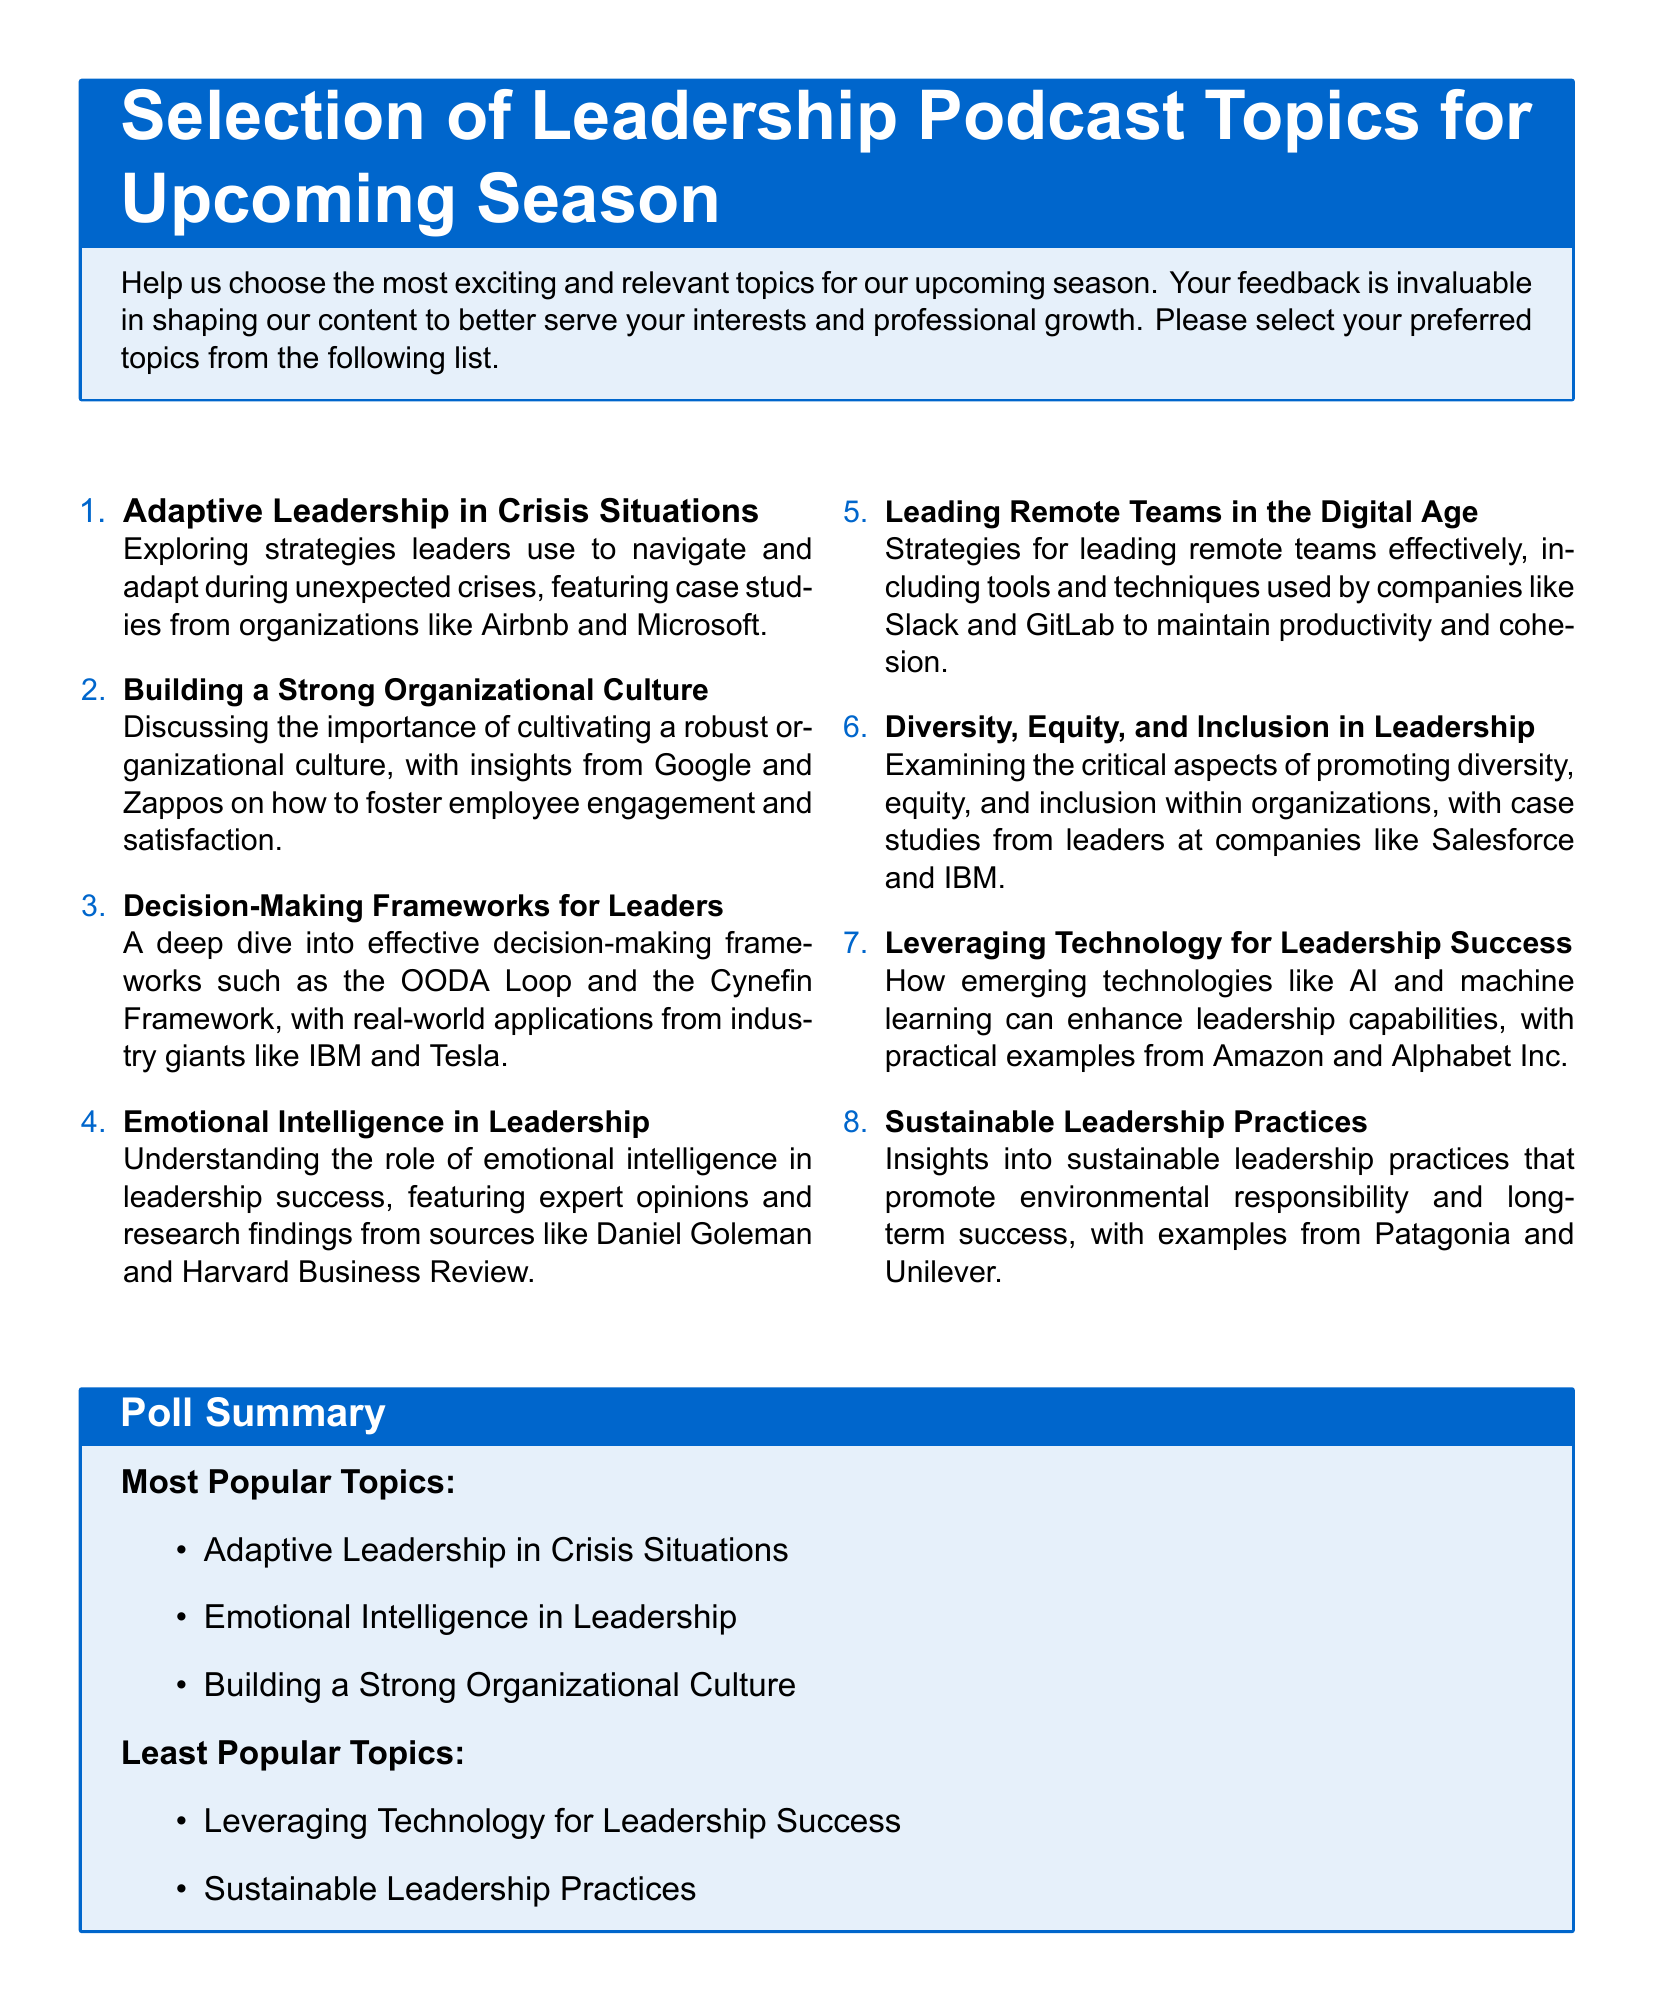What is the title of the document? The title is prominently displayed at the top of the document in a larger font.
Answer: Selection of Leadership Podcast Topics for Upcoming Season How many topics are listed in the document? The document contains a total of eight topics listed in the enumeration.
Answer: Eight Which topic explores strategies leaders use during crises? The document clearly labels the topic focused on crisis strategies.
Answer: Adaptive Leadership in Crisis Situations What are the two least popular topics according to the poll summary? The document includes a section that summarizes the most and least popular topics based on the poll.
Answer: Leveraging Technology for Leadership Success, Sustainable Leadership Practices Which company is mentioned as a case study for building organizational culture? The document provides specific examples of companies associated with each topic.
Answer: Zappos What is the focus of the topic that discusses diversity and inclusion? The document outlines the aim of the topic regarding leadership in organizations.
Answer: Diversity, Equity, and Inclusion in Leadership 